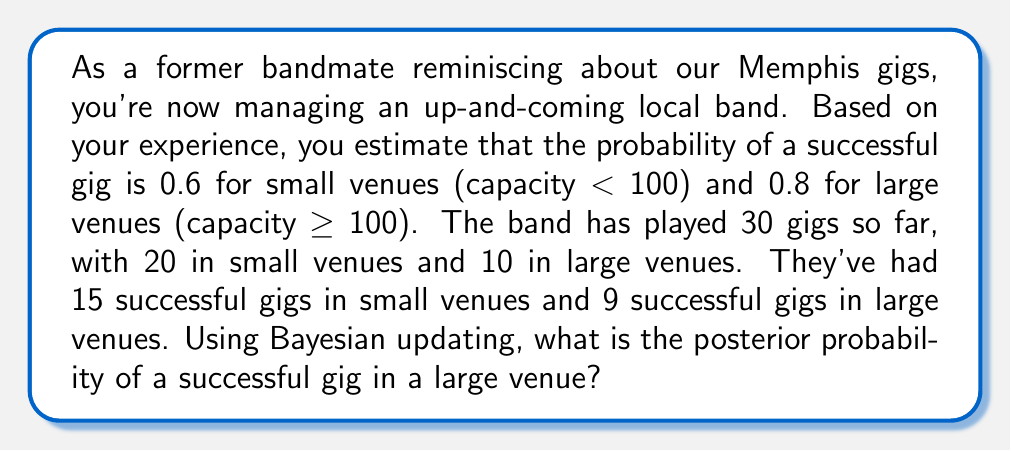What is the answer to this math problem? Let's approach this step-by-step using Bayesian updating:

1) First, we need to define our variables:
   $\theta_L$ = probability of a successful gig in a large venue
   $D$ = observed data

2) We're given the prior probability:
   $P(\theta_L) = 0.8$

3) We need to calculate the likelihood of the data given $\theta_L$. This follows a binomial distribution:
   $P(D|\theta_L) = \binom{10}{9} \theta_L^9 (1-\theta_L)^1$

4) We also need the marginal likelihood $P(D)$, which we can calculate using the law of total probability:
   $P(D) = P(D|\theta_L)P(\theta_L) + P(D|\theta_S)P(\theta_S)$
   where $\theta_S$ is the probability of success in small venues.

5) Now we can apply Bayes' theorem:

   $$P(\theta_L|D) = \frac{P(D|\theta_L)P(\theta_L)}{P(D)}$$

6) Plugging in the values:

   $$P(\theta_L|D) = \frac{\binom{10}{9} 0.8^9 (1-0.8)^1 * 0.8}{\binom{10}{9} 0.8^9 (1-0.8)^1 * 0.8 + \binom{20}{15} 0.6^{15} (1-0.6)^5 * 0.6}$$

7) Simplifying:

   $$P(\theta_L|D) = \frac{10 * 0.8^9 * 0.2 * 0.8}{10 * 0.8^9 * 0.2 * 0.8 + 15504 * 0.6^{15} * 0.4^5 * 0.6}$$

8) Calculating:

   $$P(\theta_L|D) \approx 0.8915$$
Answer: The posterior probability of a successful gig in a large venue is approximately 0.8915 or 89.15%. 